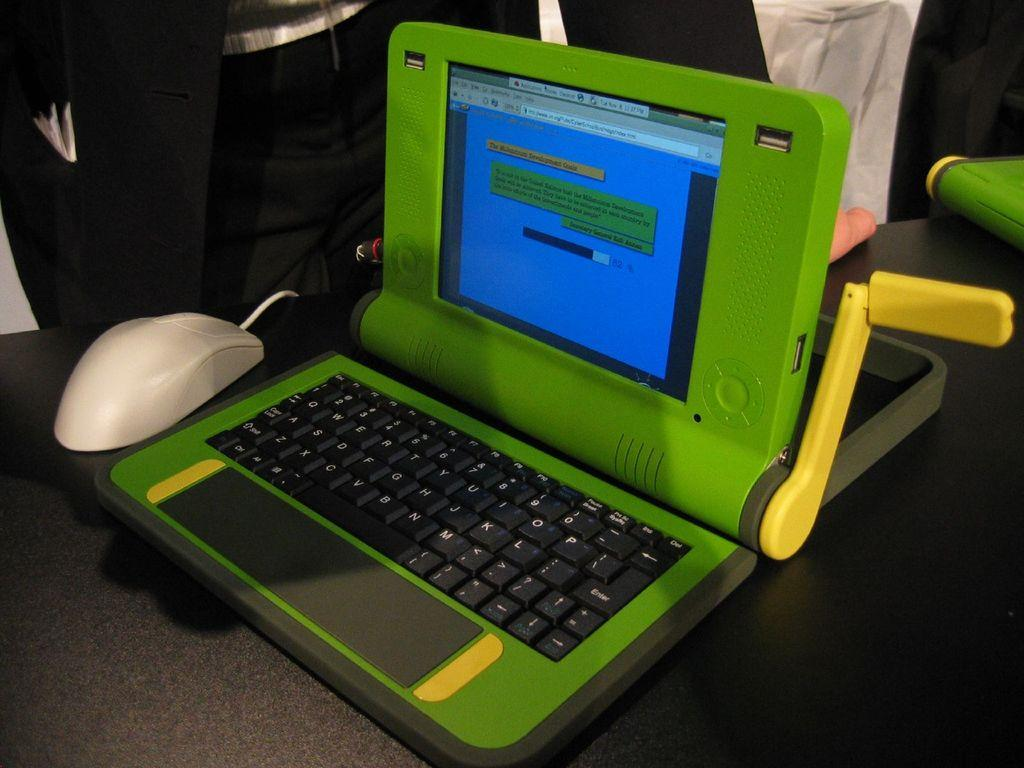What is the main object in the middle of the image? There is a laptop in the middle of the image. What is located beside the laptop? There is a white mouse beside the laptop. Can you describe the person in the background of the image? The person is standing in the background of the image and is wearing a black coat. What is the person standing near in the image? The person is standing near a table. What type of dust can be seen on the quince in the image? There is no quince or dust present in the image. 